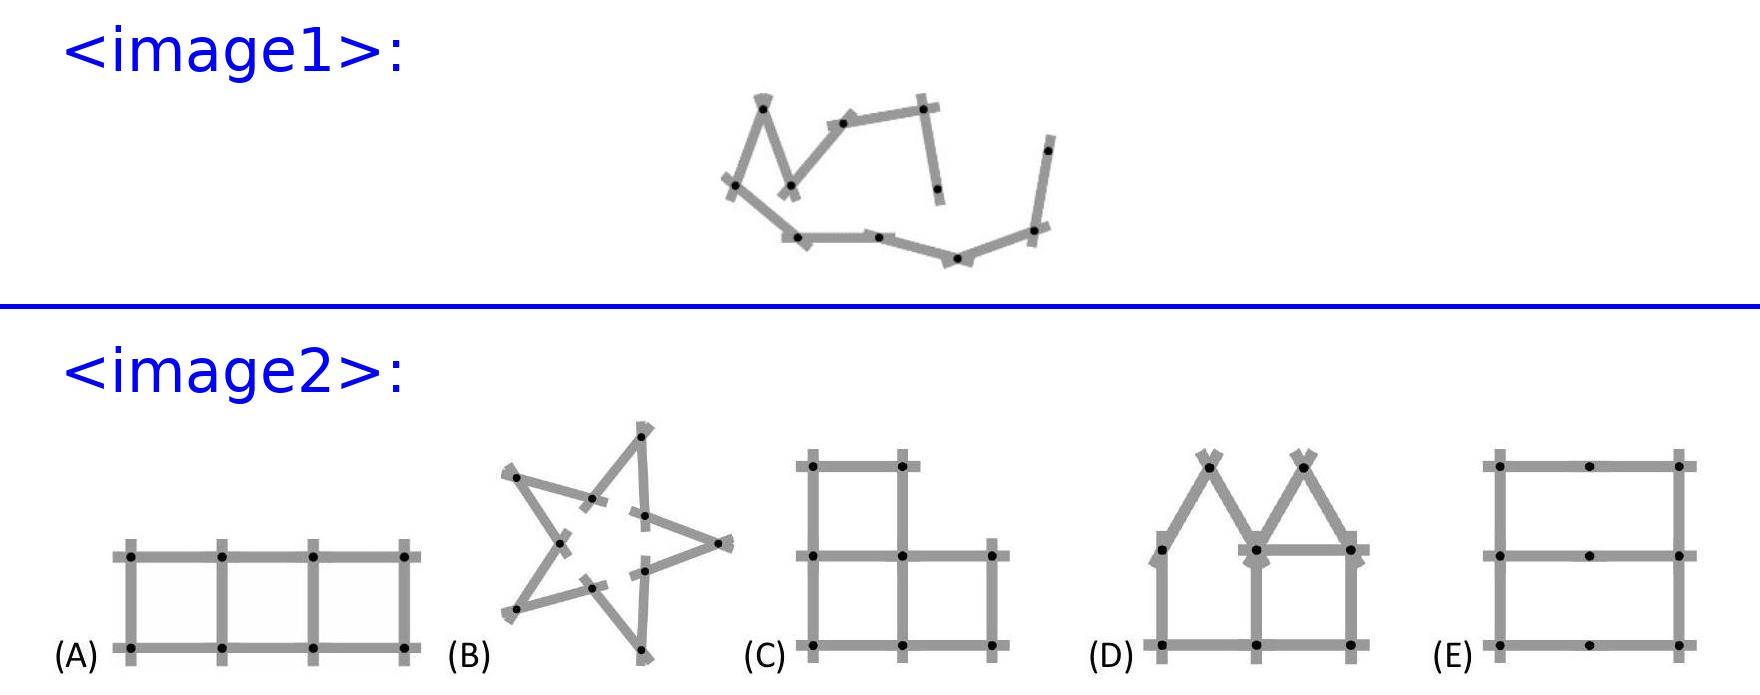Pia has a folding yardstick consisting of 10 equally long pieces. Which of the following figures can she not make? Pia cannot make figure A. This figure requires alternating angles and lengths that cannot be achieved with a folding yardstick that divides into 10 equal lengths. The lines in figure A have segments that vary in length whereas her yardstick's segments are all the same length, preventing certain bends and connections necessary for this configuration. 